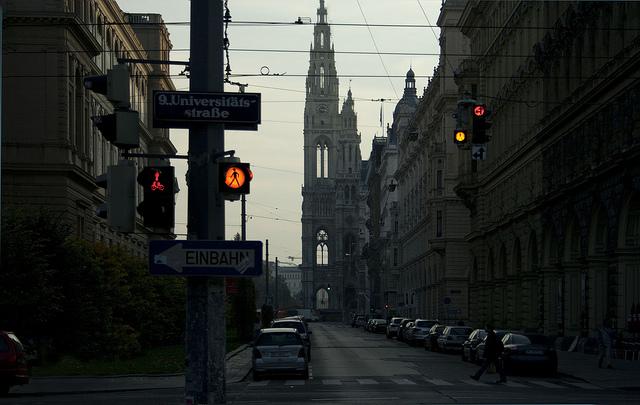Is this night or day?
Short answer required. Day. What time is the clock in the background?
Give a very brief answer. Unknown. Does the sign say to walk now?
Be succinct. No. Is this a scene in the United States?
Concise answer only. No. Is this a light for a busy district?
Keep it brief. Yes. How is the stoplight mounted?
Concise answer only. On pole. Is it safe to walk?
Be succinct. No. 